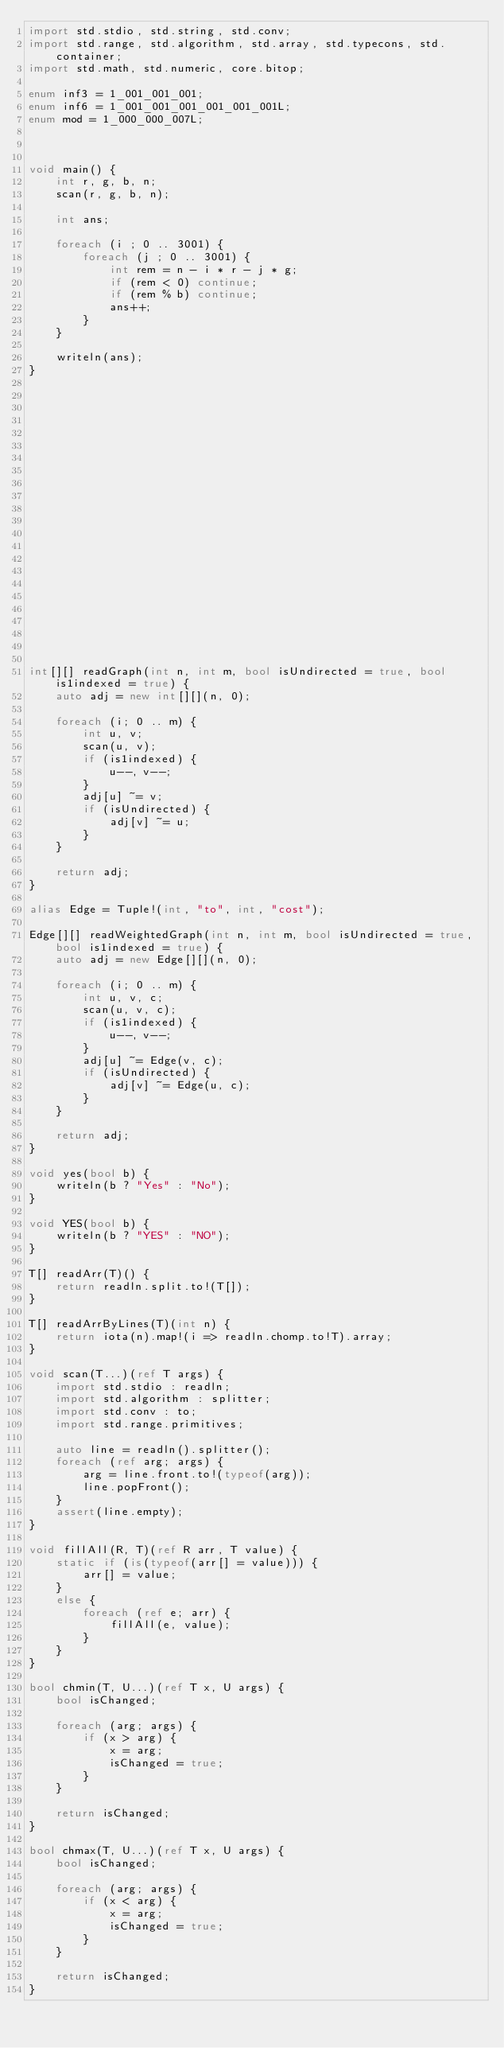Convert code to text. <code><loc_0><loc_0><loc_500><loc_500><_D_>import std.stdio, std.string, std.conv;
import std.range, std.algorithm, std.array, std.typecons, std.container;
import std.math, std.numeric, core.bitop;

enum inf3 = 1_001_001_001;
enum inf6 = 1_001_001_001_001_001_001L;
enum mod = 1_000_000_007L;



void main() {
    int r, g, b, n;
    scan(r, g, b, n);

    int ans;

    foreach (i ; 0 .. 3001) {
        foreach (j ; 0 .. 3001) {
            int rem = n - i * r - j * g;
            if (rem < 0) continue;
            if (rem % b) continue;
            ans++;
        }
    }

    writeln(ans);
}























int[][] readGraph(int n, int m, bool isUndirected = true, bool is1indexed = true) {
    auto adj = new int[][](n, 0);

    foreach (i; 0 .. m) {
        int u, v;
        scan(u, v);
        if (is1indexed) {
            u--, v--;
        }
        adj[u] ~= v;
        if (isUndirected) {
            adj[v] ~= u;
        }
    }

    return adj;
}

alias Edge = Tuple!(int, "to", int, "cost");

Edge[][] readWeightedGraph(int n, int m, bool isUndirected = true, bool is1indexed = true) {
    auto adj = new Edge[][](n, 0);

    foreach (i; 0 .. m) {
        int u, v, c;
        scan(u, v, c);
        if (is1indexed) {
            u--, v--;
        }
        adj[u] ~= Edge(v, c);
        if (isUndirected) {
            adj[v] ~= Edge(u, c);
        }
    }

    return adj;
}

void yes(bool b) {
    writeln(b ? "Yes" : "No");
}

void YES(bool b) {
    writeln(b ? "YES" : "NO");
}

T[] readArr(T)() {
    return readln.split.to!(T[]);
}

T[] readArrByLines(T)(int n) {
    return iota(n).map!(i => readln.chomp.to!T).array;
}

void scan(T...)(ref T args) {
    import std.stdio : readln;
    import std.algorithm : splitter;
    import std.conv : to;
    import std.range.primitives;

    auto line = readln().splitter();
    foreach (ref arg; args) {
        arg = line.front.to!(typeof(arg));
        line.popFront();
    }
    assert(line.empty);
}

void fillAll(R, T)(ref R arr, T value) {
    static if (is(typeof(arr[] = value))) {
        arr[] = value;
    }
    else {
        foreach (ref e; arr) {
            fillAll(e, value);
        }
    }
}

bool chmin(T, U...)(ref T x, U args) {
    bool isChanged;

    foreach (arg; args) {
        if (x > arg) {
            x = arg;
            isChanged = true;
        }
    }

    return isChanged;
}

bool chmax(T, U...)(ref T x, U args) {
    bool isChanged;

    foreach (arg; args) {
        if (x < arg) {
            x = arg;
            isChanged = true;
        }
    }

    return isChanged;
}
</code> 